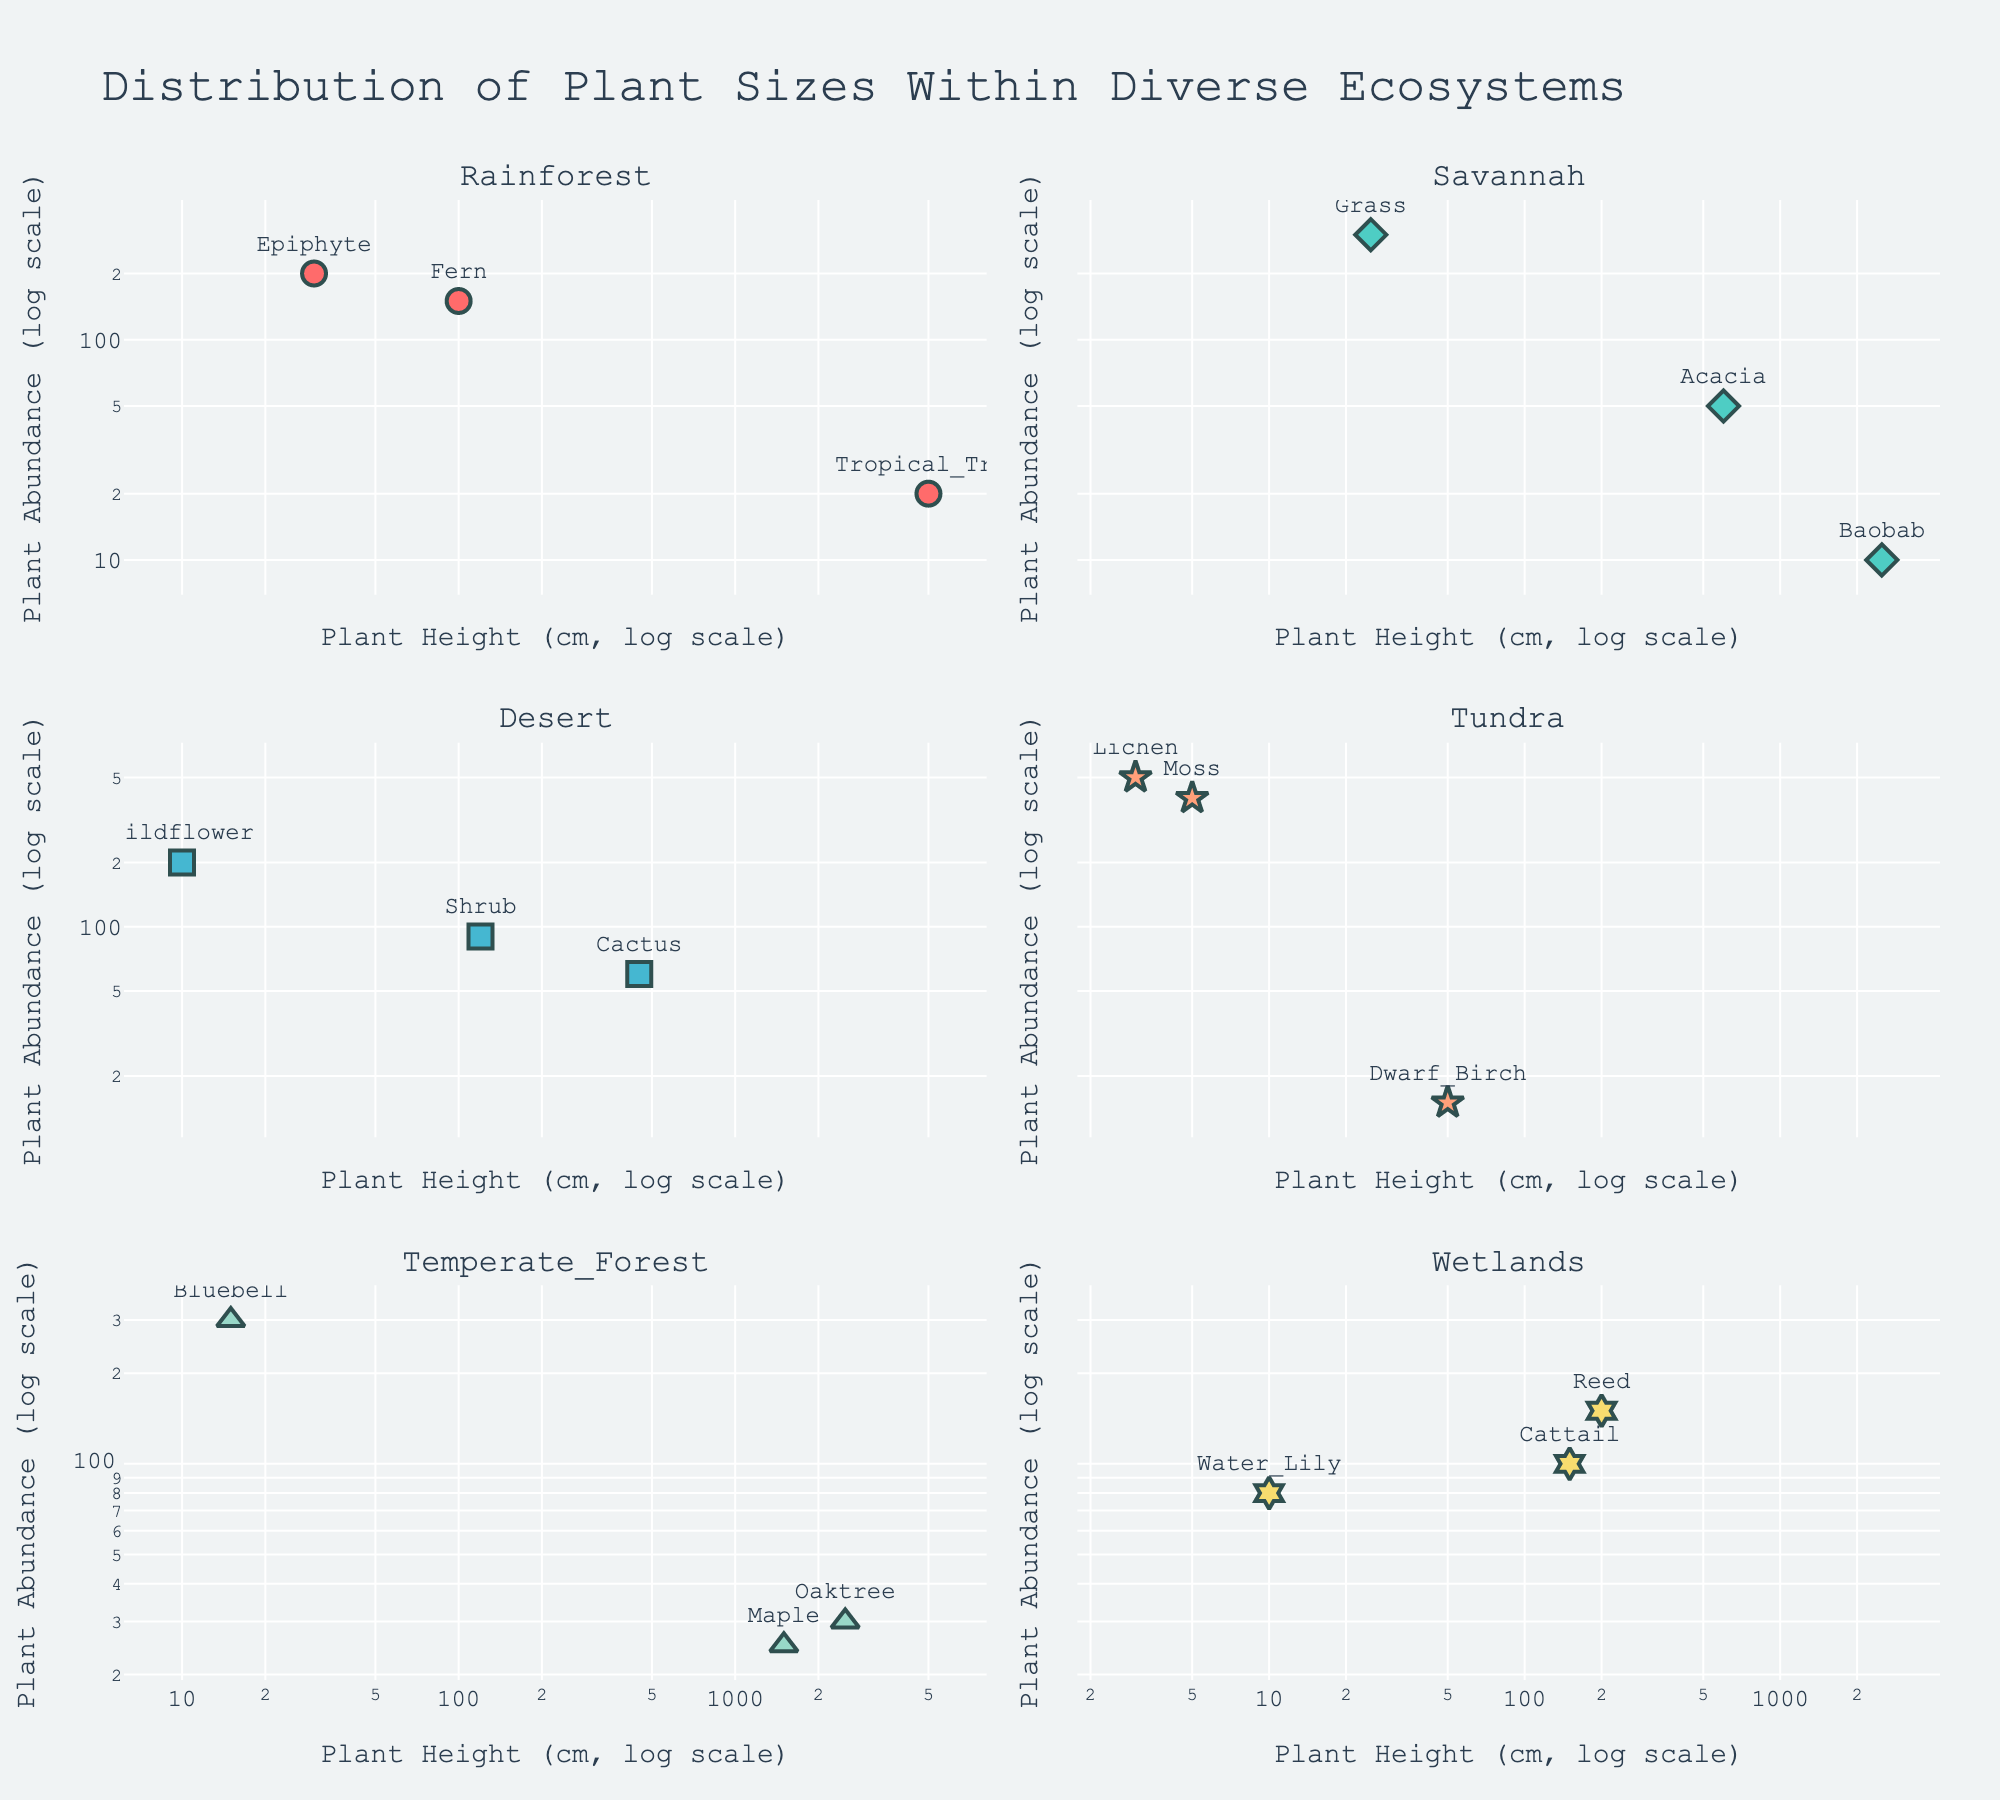What is the title of the figure? The title is prominently displayed at the top and reads "Distribution of Plant Sizes Within Diverse Ecosystems".
Answer: Distribution of Plant Sizes Within Diverse Ecosystems How many ecosystems are represented in the figure? There are six subplots, each representing a different ecosystem: Rainforest, Savannah, Desert, Tundra, Temperate Forest, and Wetlands.
Answer: 6 Which plant has the highest height in the Rainforest ecosystem? In the Rainforest subplot, "Tropical Tree" is annotated closest to the highest x-axis value, which is 5000 cm in height.
Answer: Tropical Tree Which ecosystem shows the plant with the lowest abundance? By comparing the subplots, look for the lowest y-axis value. Baobab in the Savannah ecosystem has the lowest abundance with a value of 10.
Answer: Savannah What is the range of plant heights in the Desert ecosystem? The Desert subplot shows plants ranging from the Wildflower at 10 cm to the Cactus at 450 cm.
Answer: 10 cm to 450 cm Which plant type has the highest abundance in the Tundra ecosystem? In the Tundra subplot, the Lichen is annotated near the highest y-axis value, which shows an abundance of 500.
Answer: Lichen How does the abundance of the Baobab in Savannah compare to the Dwarf Birch in Tundra? The Savannah subplot shows Baobab with an abundance of 10, while the Tundra subplot shows Dwarf Birch with an abundance of 15. Baobab's abundance is lower.
Answer: Baobab < Dwarf Birch What is the average abundance of plants in the Wetlands ecosystem? Wetlands has three plants: Reed (150), Cattail (100), and Water Lily (80). The average is calculated as (150 + 100 + 80)/3 = 110.
Answer: 110 In which ecosystem is the tallest plant observed? By comparing the x-axis values across all subplots, the Tropical Tree in the Rainforest reaches the farthest to the right with a height of 5000 cm.
Answer: Rainforest What is the median height of plants in the Temperate Forest ecosystem? Temperate Forest has three plants: Oaktree (2500 cm), Maple (1500 cm), Bluebell (15 cm). Sorted heights are [15, 1500, 2500], and the median is 1500 cm.
Answer: 1500 cm 